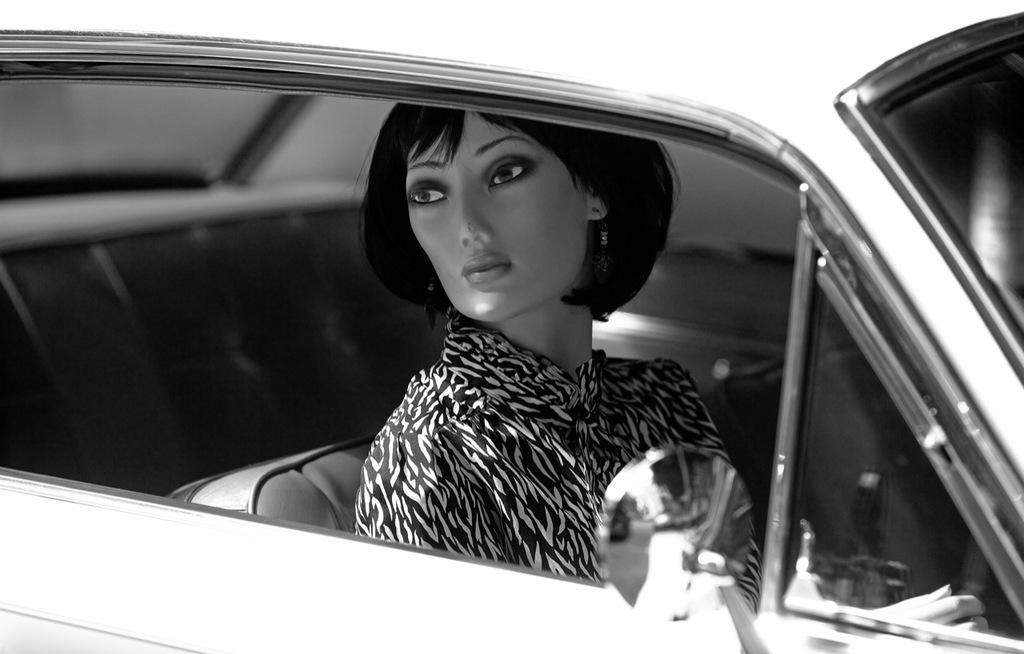What is the color scheme of the image? The image is black and white. What can be seen in the image? There is a girl sitting in a car in the image. What type of holiday is the girl celebrating in the image? There is no indication of a holiday in the image, as it is black and white and only shows a girl sitting in a car. What parcel is the girl holding in the image? There is no parcel visible in the image; the girl is simply sitting in a car. 